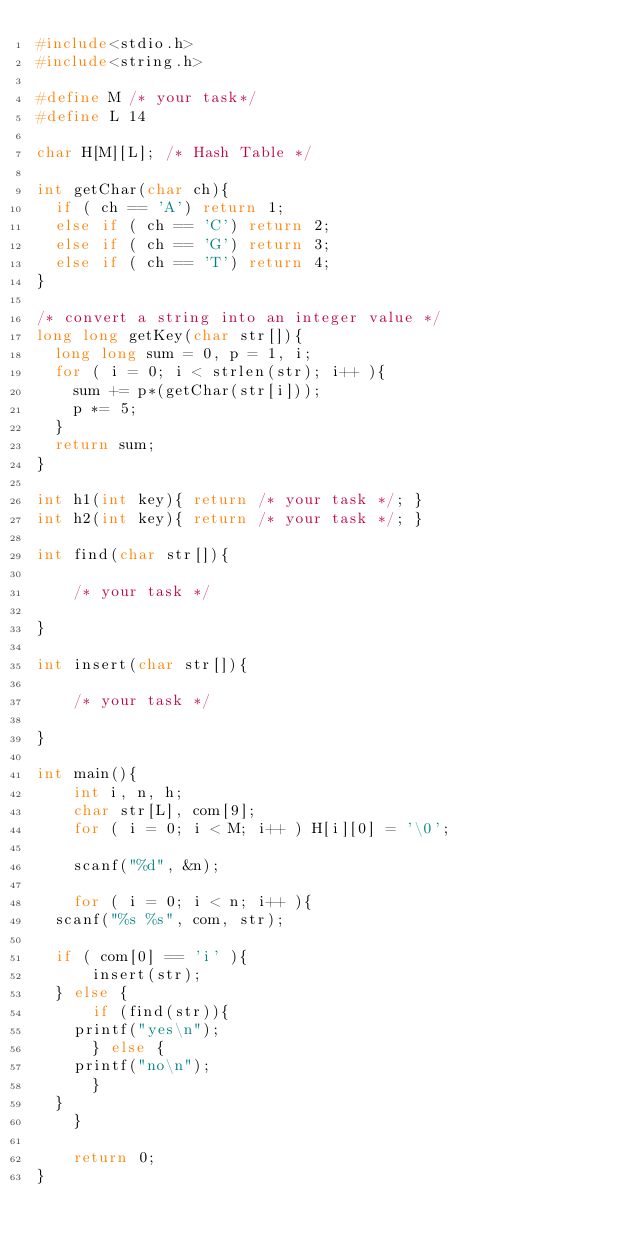Convert code to text. <code><loc_0><loc_0><loc_500><loc_500><_C_>#include<stdio.h>
#include<string.h>

#define M /* your task*/
#define L 14

char H[M][L]; /* Hash Table */

int getChar(char ch){
  if ( ch == 'A') return 1;
  else if ( ch == 'C') return 2;
  else if ( ch == 'G') return 3;
  else if ( ch == 'T') return 4;
}

/* convert a string into an integer value */
long long getKey(char str[]){
  long long sum = 0, p = 1, i;
  for ( i = 0; i < strlen(str); i++ ){
    sum += p*(getChar(str[i]));
    p *= 5;
  }
  return sum;
}

int h1(int key){ return /* your task */; }
int h2(int key){ return /* your task */; }

int find(char str[]){

    /* your task */

}

int insert(char str[]){

    /* your task */

}

int main(){
    int i, n, h;
    char str[L], com[9];
    for ( i = 0; i < M; i++ ) H[i][0] = '\0';
    
    scanf("%d", &n);
    
    for ( i = 0; i < n; i++ ){
	scanf("%s %s", com, str);
	
	if ( com[0] == 'i' ){
	    insert(str);
	} else {
	    if (find(str)){
		printf("yes\n");
	    } else {
		printf("no\n");
	    }
	}
    }

    return 0;
}</code> 